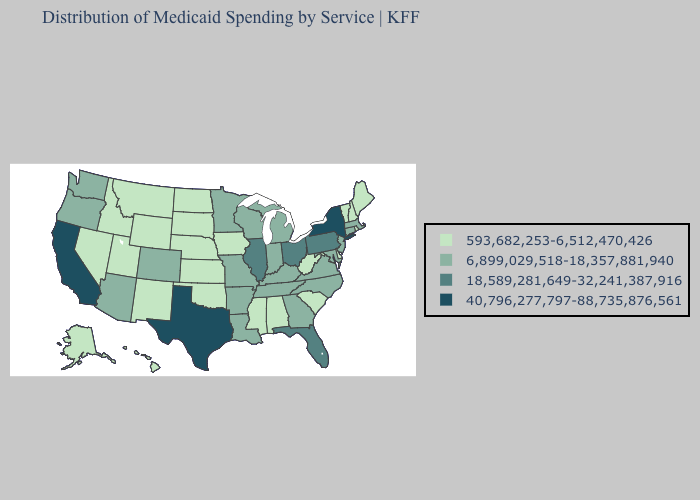What is the value of Illinois?
Keep it brief. 18,589,281,649-32,241,387,916. Among the states that border Colorado , which have the highest value?
Answer briefly. Arizona. Does the first symbol in the legend represent the smallest category?
Concise answer only. Yes. Does the first symbol in the legend represent the smallest category?
Concise answer only. Yes. Does North Carolina have the highest value in the USA?
Give a very brief answer. No. Does Maine have the highest value in the Northeast?
Give a very brief answer. No. How many symbols are there in the legend?
Quick response, please. 4. Which states have the highest value in the USA?
Give a very brief answer. California, New York, Texas. Does California have the highest value in the West?
Be succinct. Yes. Name the states that have a value in the range 593,682,253-6,512,470,426?
Concise answer only. Alabama, Alaska, Delaware, Hawaii, Idaho, Iowa, Kansas, Maine, Mississippi, Montana, Nebraska, Nevada, New Hampshire, New Mexico, North Dakota, Oklahoma, Rhode Island, South Carolina, South Dakota, Utah, Vermont, West Virginia, Wyoming. Name the states that have a value in the range 593,682,253-6,512,470,426?
Concise answer only. Alabama, Alaska, Delaware, Hawaii, Idaho, Iowa, Kansas, Maine, Mississippi, Montana, Nebraska, Nevada, New Hampshire, New Mexico, North Dakota, Oklahoma, Rhode Island, South Carolina, South Dakota, Utah, Vermont, West Virginia, Wyoming. Does Hawaii have the highest value in the USA?
Short answer required. No. Does Indiana have the lowest value in the USA?
Quick response, please. No. What is the value of South Carolina?
Answer briefly. 593,682,253-6,512,470,426. What is the highest value in states that border Kansas?
Keep it brief. 6,899,029,518-18,357,881,940. 